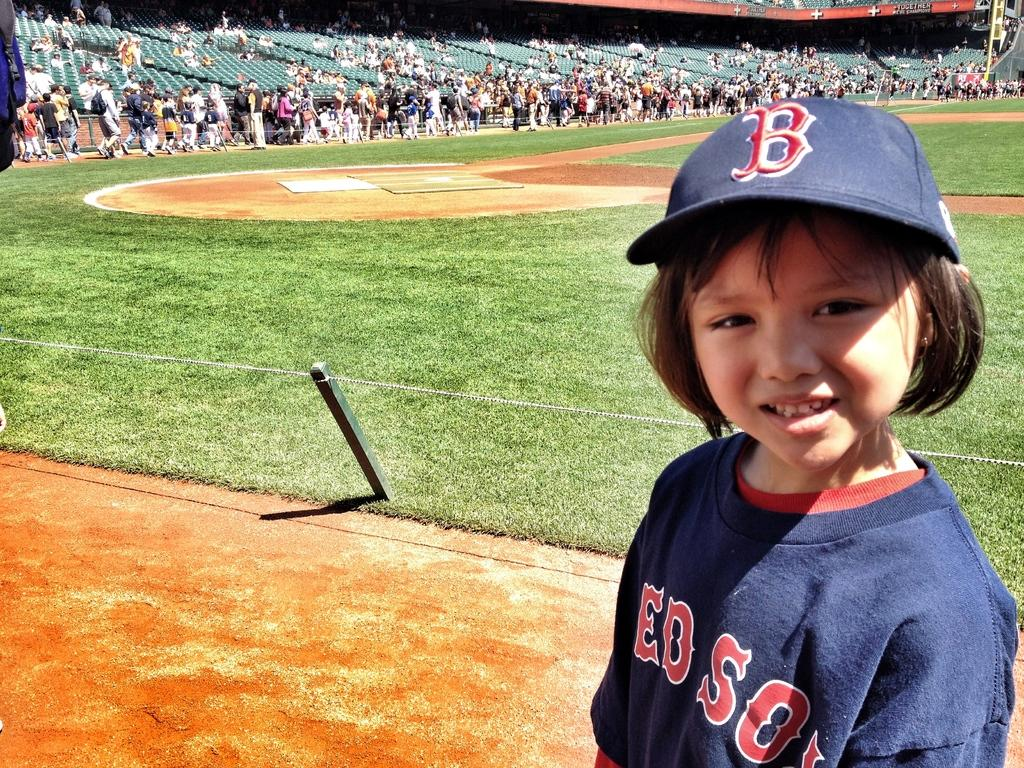Provide a one-sentence caption for the provided image. A young child on a baseball diamond wearing RedSox clothing. 